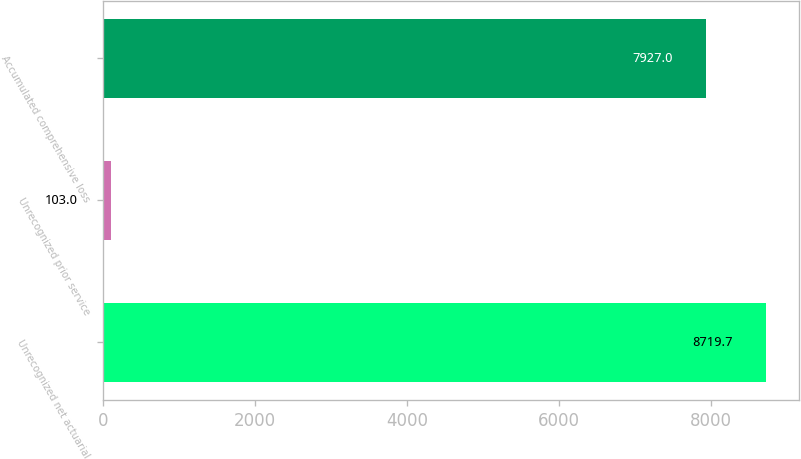Convert chart. <chart><loc_0><loc_0><loc_500><loc_500><bar_chart><fcel>Unrecognized net actuarial<fcel>Unrecognized prior service<fcel>Accumulated comprehensive loss<nl><fcel>8719.7<fcel>103<fcel>7927<nl></chart> 